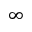<formula> <loc_0><loc_0><loc_500><loc_500>\infty</formula> 